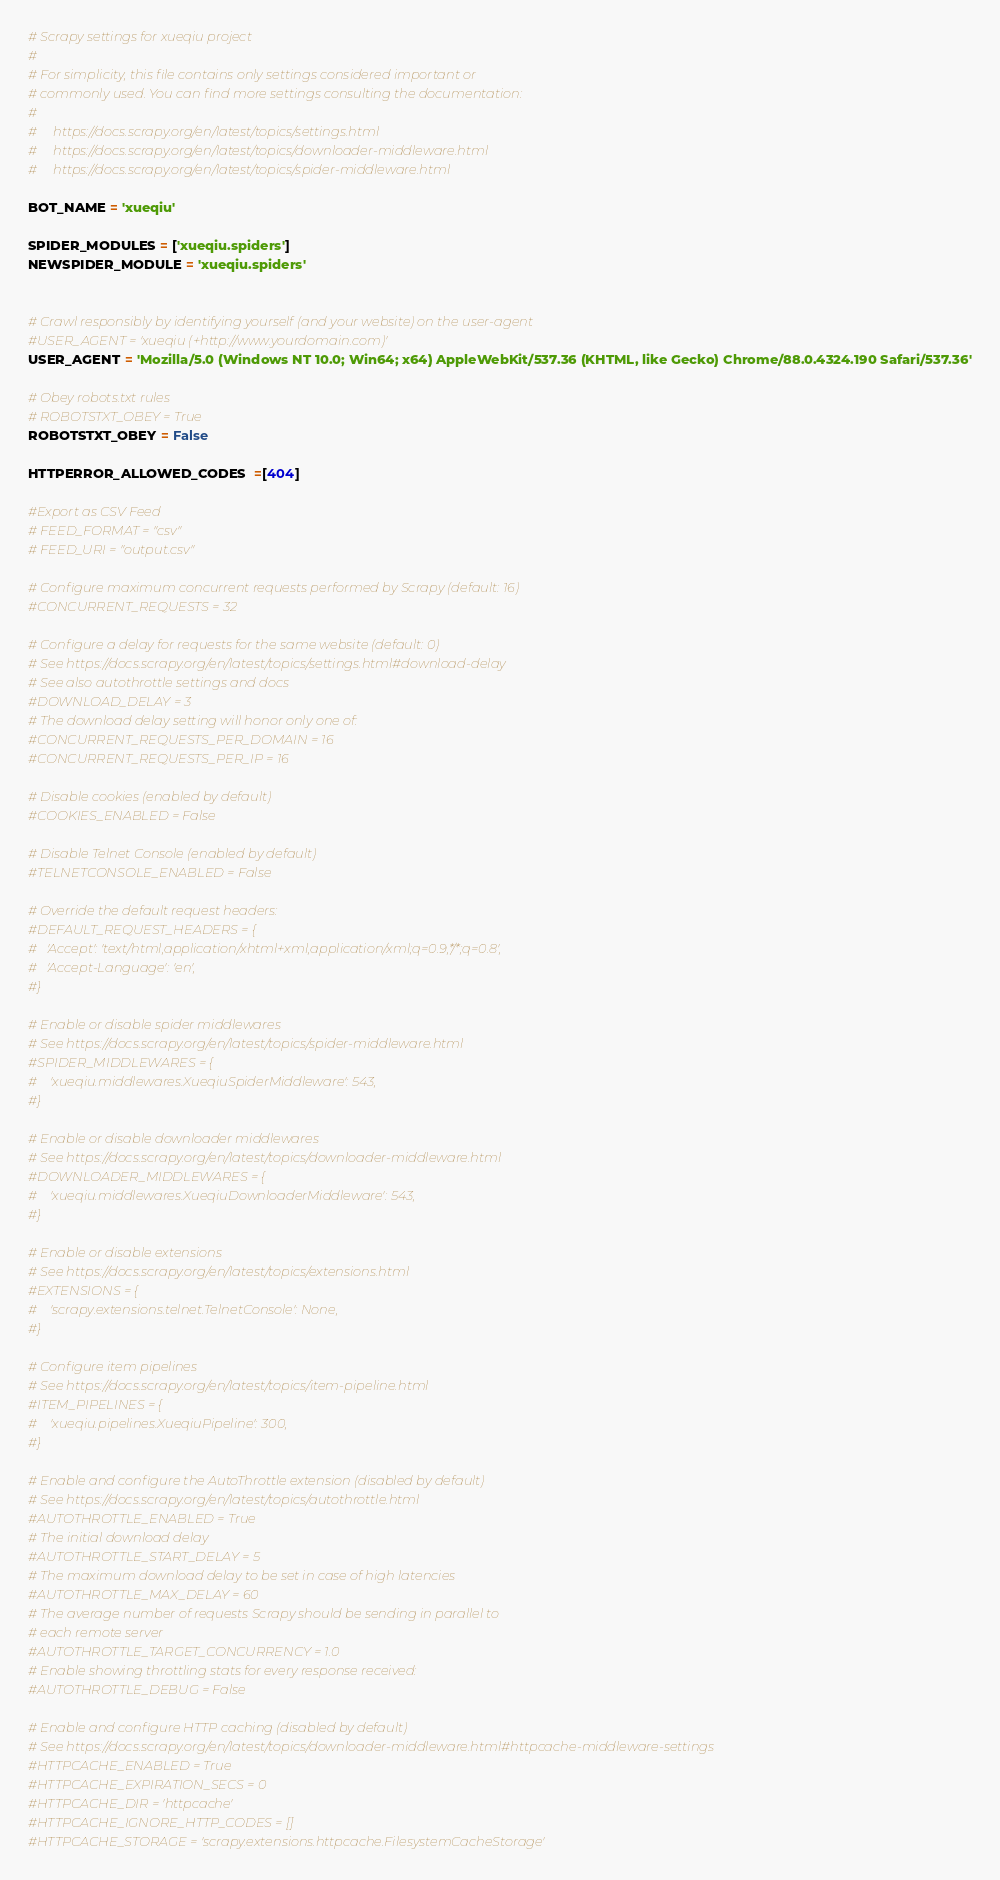<code> <loc_0><loc_0><loc_500><loc_500><_Python_># Scrapy settings for xueqiu project
#
# For simplicity, this file contains only settings considered important or
# commonly used. You can find more settings consulting the documentation:
#
#     https://docs.scrapy.org/en/latest/topics/settings.html
#     https://docs.scrapy.org/en/latest/topics/downloader-middleware.html
#     https://docs.scrapy.org/en/latest/topics/spider-middleware.html

BOT_NAME = 'xueqiu'

SPIDER_MODULES = ['xueqiu.spiders']
NEWSPIDER_MODULE = 'xueqiu.spiders'


# Crawl responsibly by identifying yourself (and your website) on the user-agent
#USER_AGENT = 'xueqiu (+http://www.yourdomain.com)'
USER_AGENT = 'Mozilla/5.0 (Windows NT 10.0; Win64; x64) AppleWebKit/537.36 (KHTML, like Gecko) Chrome/88.0.4324.190 Safari/537.36'

# Obey robots.txt rules
# ROBOTSTXT_OBEY = True
ROBOTSTXT_OBEY = False

HTTPERROR_ALLOWED_CODES  =[404]

#Export as CSV Feed
# FEED_FORMAT = "csv"
# FEED_URI = "output.csv"

# Configure maximum concurrent requests performed by Scrapy (default: 16)
#CONCURRENT_REQUESTS = 32

# Configure a delay for requests for the same website (default: 0)
# See https://docs.scrapy.org/en/latest/topics/settings.html#download-delay
# See also autothrottle settings and docs
#DOWNLOAD_DELAY = 3
# The download delay setting will honor only one of:
#CONCURRENT_REQUESTS_PER_DOMAIN = 16
#CONCURRENT_REQUESTS_PER_IP = 16

# Disable cookies (enabled by default)
#COOKIES_ENABLED = False

# Disable Telnet Console (enabled by default)
#TELNETCONSOLE_ENABLED = False

# Override the default request headers:
#DEFAULT_REQUEST_HEADERS = {
#   'Accept': 'text/html,application/xhtml+xml,application/xml;q=0.9,*/*;q=0.8',
#   'Accept-Language': 'en',
#}

# Enable or disable spider middlewares
# See https://docs.scrapy.org/en/latest/topics/spider-middleware.html
#SPIDER_MIDDLEWARES = {
#    'xueqiu.middlewares.XueqiuSpiderMiddleware': 543,
#}

# Enable or disable downloader middlewares
# See https://docs.scrapy.org/en/latest/topics/downloader-middleware.html
#DOWNLOADER_MIDDLEWARES = {
#    'xueqiu.middlewares.XueqiuDownloaderMiddleware': 543,
#}

# Enable or disable extensions
# See https://docs.scrapy.org/en/latest/topics/extensions.html
#EXTENSIONS = {
#    'scrapy.extensions.telnet.TelnetConsole': None,
#}

# Configure item pipelines
# See https://docs.scrapy.org/en/latest/topics/item-pipeline.html
#ITEM_PIPELINES = {
#    'xueqiu.pipelines.XueqiuPipeline': 300,
#}

# Enable and configure the AutoThrottle extension (disabled by default)
# See https://docs.scrapy.org/en/latest/topics/autothrottle.html
#AUTOTHROTTLE_ENABLED = True
# The initial download delay
#AUTOTHROTTLE_START_DELAY = 5
# The maximum download delay to be set in case of high latencies
#AUTOTHROTTLE_MAX_DELAY = 60
# The average number of requests Scrapy should be sending in parallel to
# each remote server
#AUTOTHROTTLE_TARGET_CONCURRENCY = 1.0
# Enable showing throttling stats for every response received:
#AUTOTHROTTLE_DEBUG = False

# Enable and configure HTTP caching (disabled by default)
# See https://docs.scrapy.org/en/latest/topics/downloader-middleware.html#httpcache-middleware-settings
#HTTPCACHE_ENABLED = True
#HTTPCACHE_EXPIRATION_SECS = 0
#HTTPCACHE_DIR = 'httpcache'
#HTTPCACHE_IGNORE_HTTP_CODES = []
#HTTPCACHE_STORAGE = 'scrapy.extensions.httpcache.FilesystemCacheStorage'
</code> 